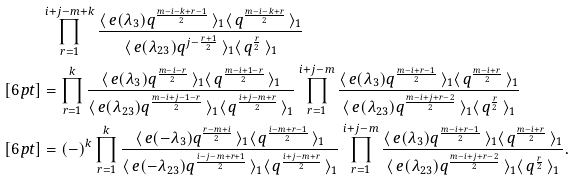Convert formula to latex. <formula><loc_0><loc_0><loc_500><loc_500>& \prod _ { r = 1 } ^ { i + j - m + k } \frac { \langle \, e ( \lambda _ { 3 } ) q ^ { \frac { m - i - k + r - 1 } { 2 } } \, \rangle _ { 1 } \langle \, q ^ { \frac { m - i - k + r } { 2 } } \, \rangle _ { 1 } } { \langle \, e ( \lambda _ { 2 3 } ) q ^ { j - \frac { r + 1 } { 2 } } \, \rangle _ { 1 } \langle \, q ^ { \frac { r } { 2 } } \, \rangle _ { 1 } } \\ [ 6 p t ] & = \prod _ { r = 1 } ^ { k } \frac { \langle \, e ( \lambda _ { 3 } ) q ^ { \frac { m - i - r } { 2 } } \, \rangle _ { 1 } \langle \, q ^ { \frac { m - i + 1 - r } { 2 } } \, \rangle _ { 1 } } { \langle \, e ( \lambda _ { 2 3 } ) q ^ { \frac { m - i + j - 1 - r } { 2 } } \, \rangle _ { 1 } \langle \, q ^ { \frac { i + j - m + r } { 2 } } \, \rangle _ { 1 } } \prod _ { r = 1 } ^ { i + j - m } \frac { \langle \, e ( \lambda _ { 3 } ) q ^ { \frac { m - i + r - 1 } { 2 } } \, \rangle _ { 1 } \langle \, q ^ { \frac { m - i + r } { 2 } } \, \rangle _ { 1 } } { \langle \, e ( \lambda _ { 2 3 } ) q ^ { \frac { m - i + j + r - 2 } { 2 } } \, \rangle _ { 1 } \langle \, q ^ { \frac { r } { 2 } } \, \rangle _ { 1 } } \\ [ 6 p t ] & = ( - ) ^ { k } \prod _ { r = 1 } ^ { k } \frac { \langle \, e ( - \lambda _ { 3 } ) q ^ { \frac { r - m + i } { 2 } } \, \rangle _ { 1 } \langle \, q ^ { \frac { i - m + r - 1 } { 2 } } \, \rangle _ { 1 } } { \langle \, e ( - \lambda _ { 2 3 } ) q ^ { \frac { i - j - m + r + 1 } { 2 } } \, \rangle _ { 1 } \langle \, q ^ { \frac { i + j - m + r } { 2 } } \, \rangle _ { 1 } } \prod _ { r = 1 } ^ { i + j - m } \frac { \langle \, e ( \lambda _ { 3 } ) q ^ { \frac { m - i + r - 1 } { 2 } } \, \rangle _ { 1 } \langle \, q ^ { \frac { m - i + r } { 2 } } \, \rangle _ { 1 } } { \langle \, e ( \lambda _ { 2 3 } ) q ^ { \frac { m - i + j + r - 2 } { 2 } } \, \rangle _ { 1 } \langle \, q ^ { \frac { r } { 2 } } \, \rangle _ { 1 } } . \\</formula> 